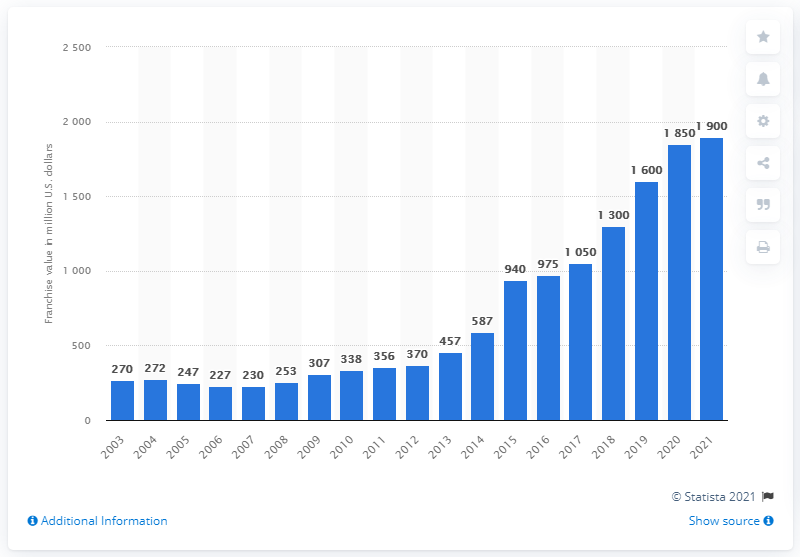Identify some key points in this picture. The estimated value of the Portland Trail Blazers in 2021 was 1.9 billion dollars. 